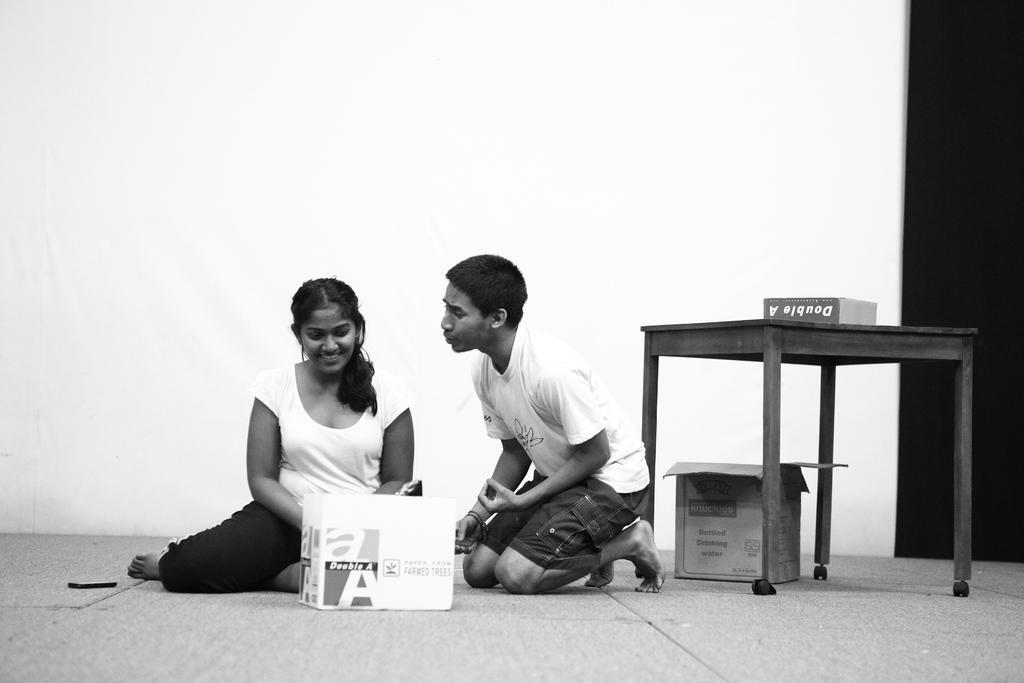Describe this image in one or two sentences. In the picture we can find a man and a woman sitting on a floor. Besides to them there is a table, under the table there is a box and the woman is smiling, Beside her there is a mobile phone. In the background there is a wall. 